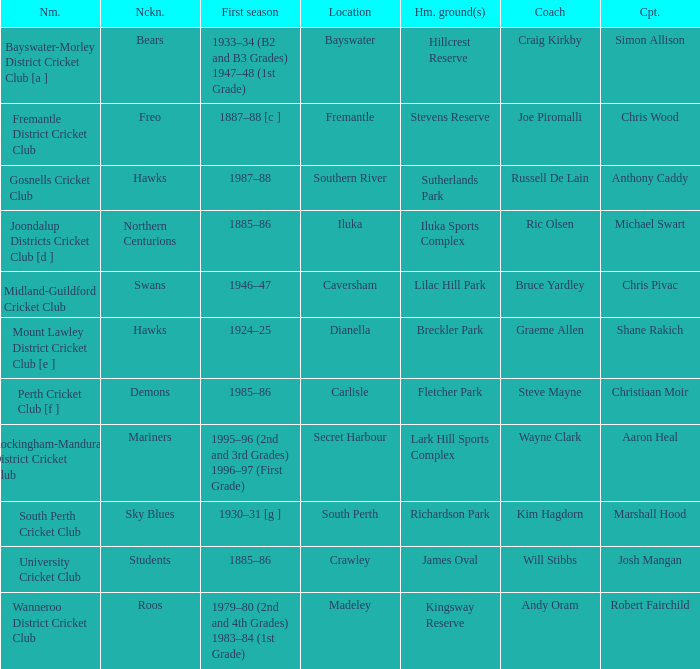What is the dates where Hillcrest Reserve is the home grounds? 1933–34 (B2 and B3 Grades) 1947–48 (1st Grade). 